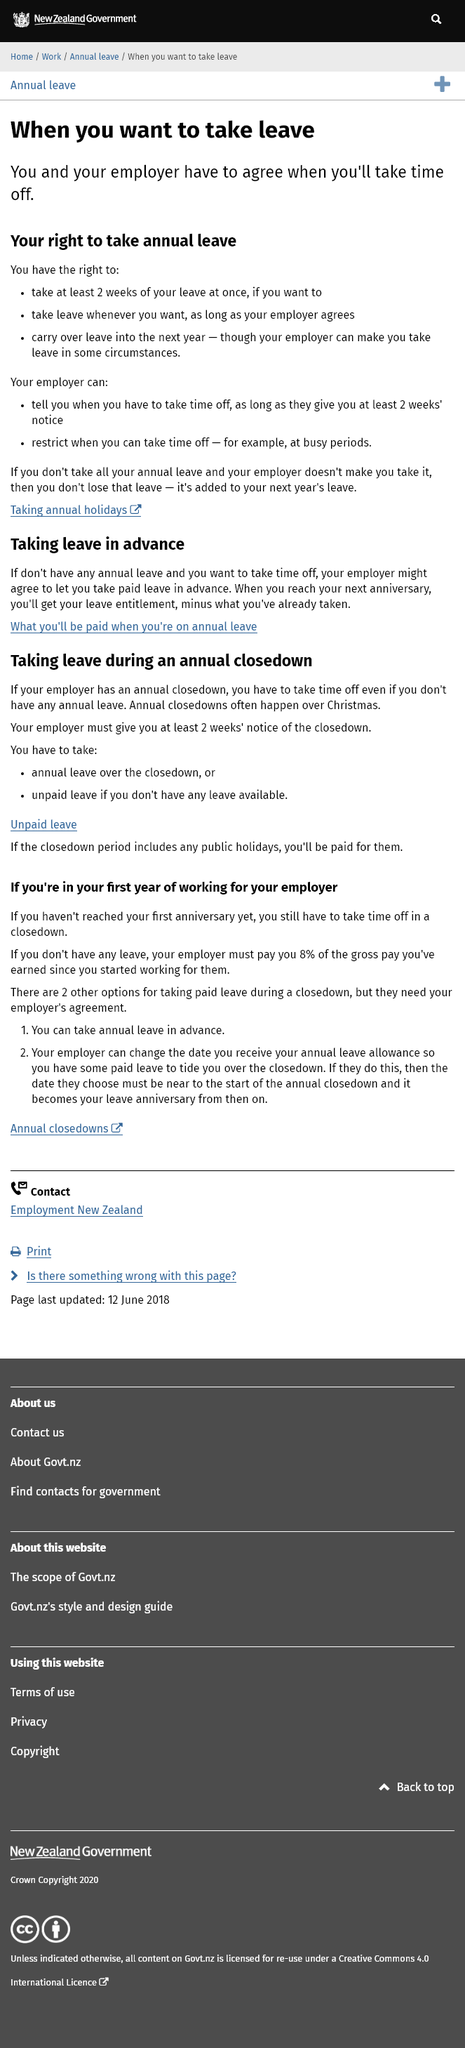Outline some significant characteristics in this image. It is required that you and your employer agree on the date of your time off. It is required for an employer to provide at least two weeks' notice to an employee if they are informed of the time off that they are required to take. Under the law, you have the right to take at least 2 weeks of annual leave at once, to take leave whenever you want as long as your employer agrees, and to carry over leave into the next year, however, your employer has the right to make you take leave in certain circumstances. 